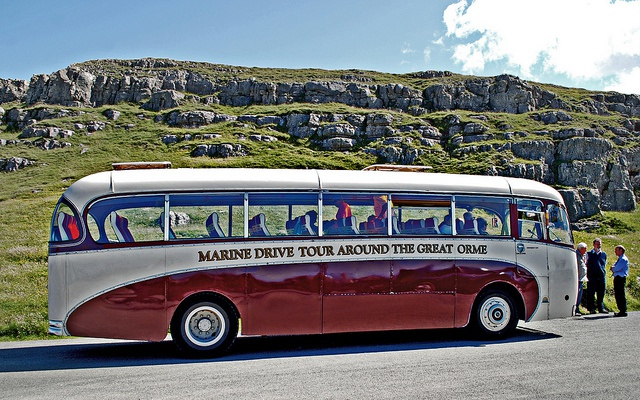Describe the objects in this image and their specific colors. I can see bus in darkgray, maroon, black, and white tones, people in darkgray, black, navy, maroon, and blue tones, people in darkgray, black, blue, olive, and darkblue tones, people in darkgray, navy, and purple tones, and people in darkgray, black, navy, white, and gray tones in this image. 